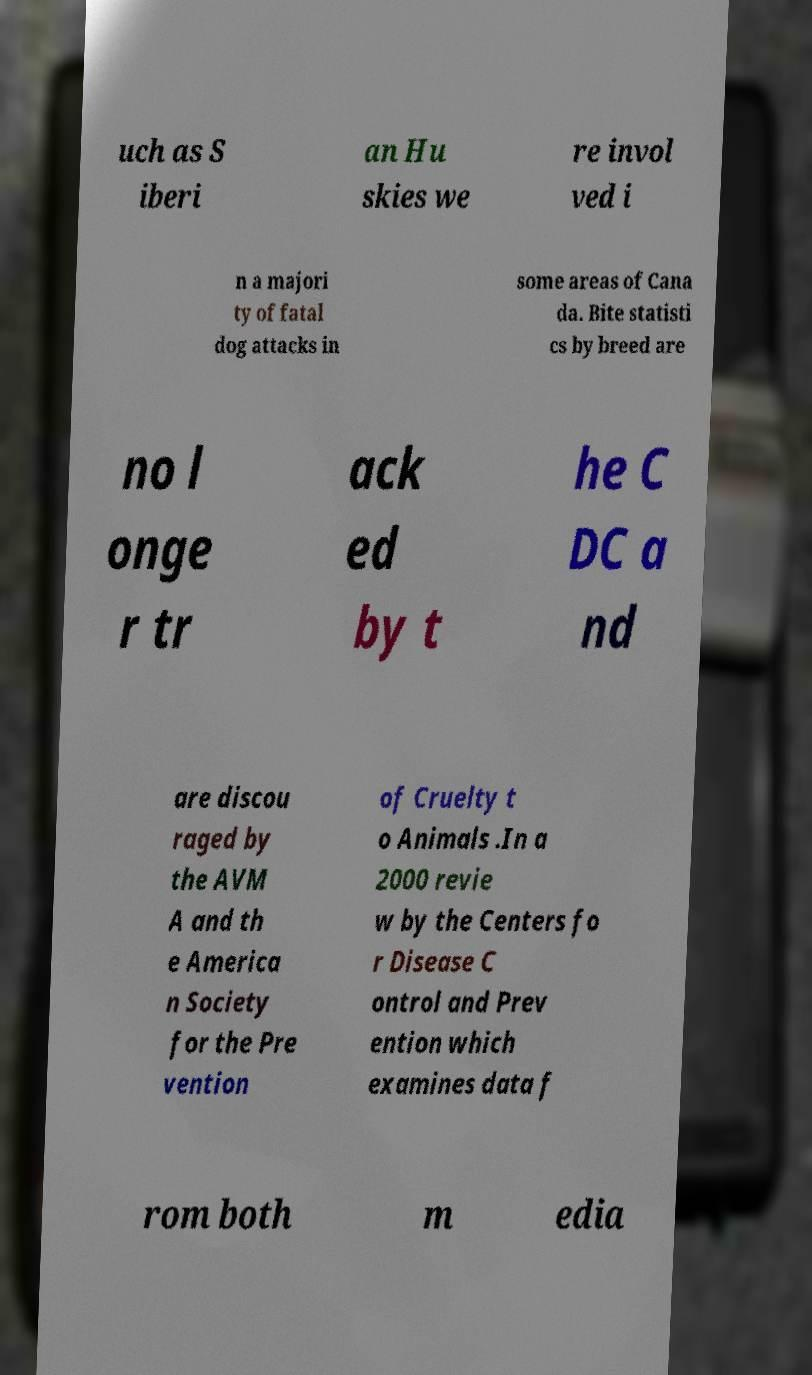Can you accurately transcribe the text from the provided image for me? uch as S iberi an Hu skies we re invol ved i n a majori ty of fatal dog attacks in some areas of Cana da. Bite statisti cs by breed are no l onge r tr ack ed by t he C DC a nd are discou raged by the AVM A and th e America n Society for the Pre vention of Cruelty t o Animals .In a 2000 revie w by the Centers fo r Disease C ontrol and Prev ention which examines data f rom both m edia 